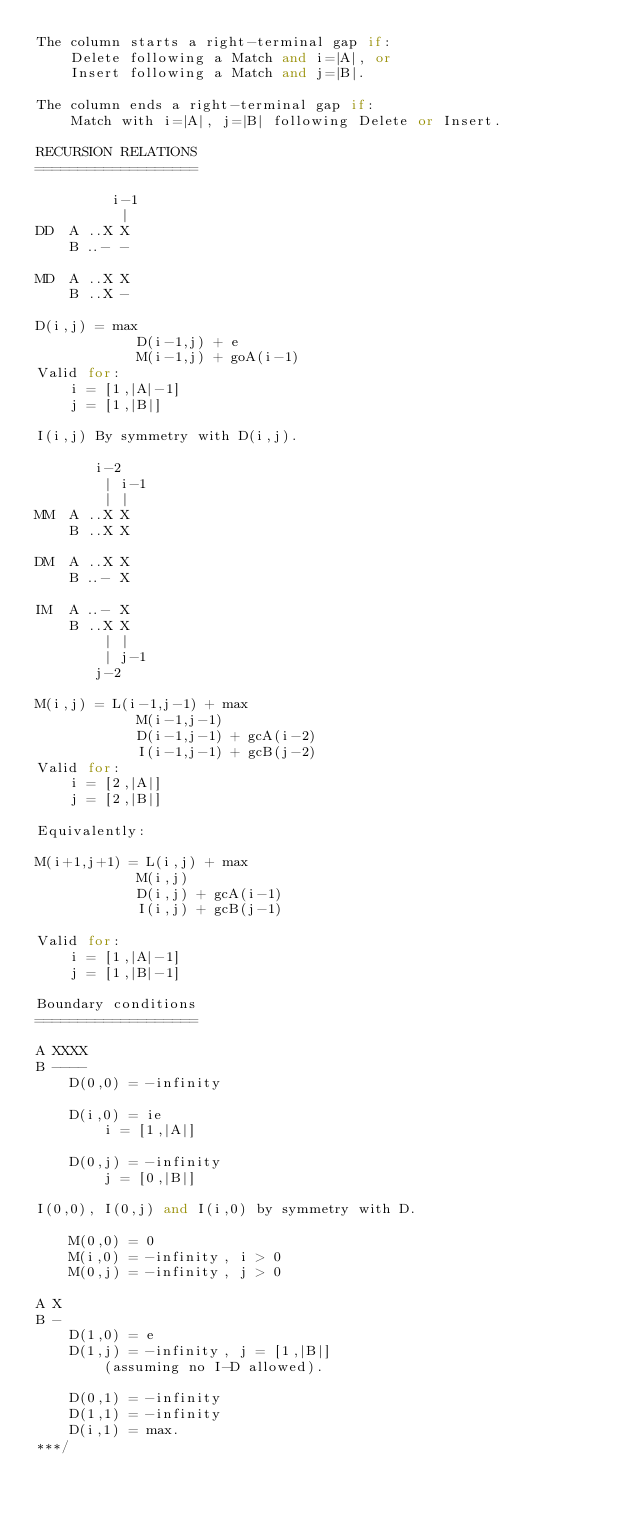Convert code to text. <code><loc_0><loc_0><loc_500><loc_500><_C++_>The column starts a right-terminal gap if:
	Delete following a Match and i=|A|, or
	Insert following a Match and j=|B|.

The column ends a right-terminal gap if:
	Match with i=|A|, j=|B| following Delete or Insert.
	
RECURSION RELATIONS
===================

         i-1
          |
DD	A ..X X
	B ..- -

MD	A ..X X
	B ..X -

D(i,j) = max
			D(i-1,j) + e
			M(i-1,j) + goA(i-1)
Valid for:
	i = [1,|A|-1]
	j = [1,|B|]

I(i,j) By symmetry with D(i,j).

       i-2
        | i-1
		| |
MM	A ..X X
	B ..X X

DM	A ..X X
	B ..- X

IM  A ..- X
	B ..X X
	    | |
		| j-1
	   j-2

M(i,j) = L(i-1,j-1) + max
			M(i-1,j-1)
			D(i-1,j-1) + gcA(i-2)
			I(i-1,j-1) + gcB(j-2)
Valid for:
	i = [2,|A|]
	j = [2,|B|]

Equivalently:

M(i+1,j+1) = L(i,j) + max
			M(i,j)
			D(i,j) + gcA(i-1)
			I(i,j) + gcB(j-1)

Valid for:
	i = [1,|A|-1]
	j = [1,|B|-1]

Boundary conditions
===================

A XXXX
B ----
	D(0,0) = -infinity

	D(i,0) = ie
		i = [1,|A|]

	D(0,j) = -infinity
		j = [0,|B|]

I(0,0), I(0,j) and I(i,0) by symmetry with D.

	M(0,0) = 0
	M(i,0) = -infinity, i > 0
	M(0,j) = -infinity, j > 0

A X
B -
	D(1,0) = e
	D(1,j) = -infinity, j = [1,|B|]
		(assuming no I-D allowed).

	D(0,1) = -infinity
	D(1,1) = -infinity
	D(i,1) = max.
***/
</code> 